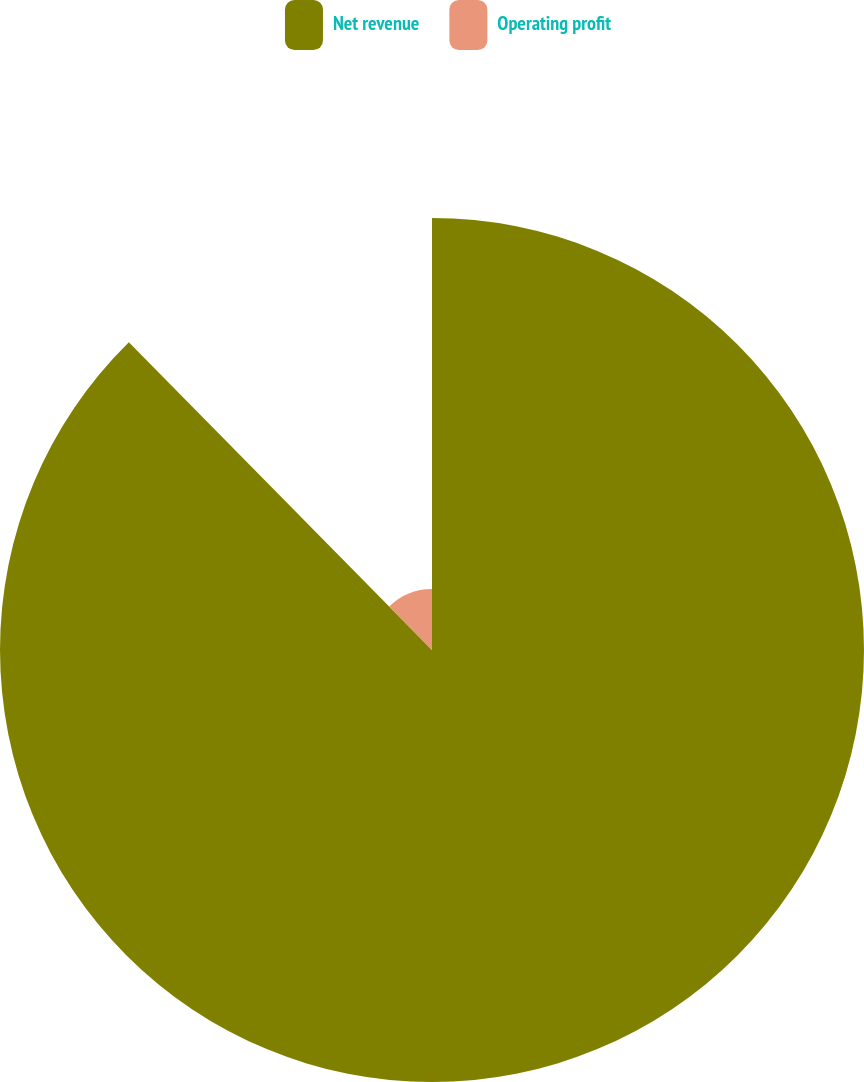Convert chart. <chart><loc_0><loc_0><loc_500><loc_500><pie_chart><fcel>Net revenue<fcel>Operating profit<nl><fcel>87.62%<fcel>12.38%<nl></chart> 